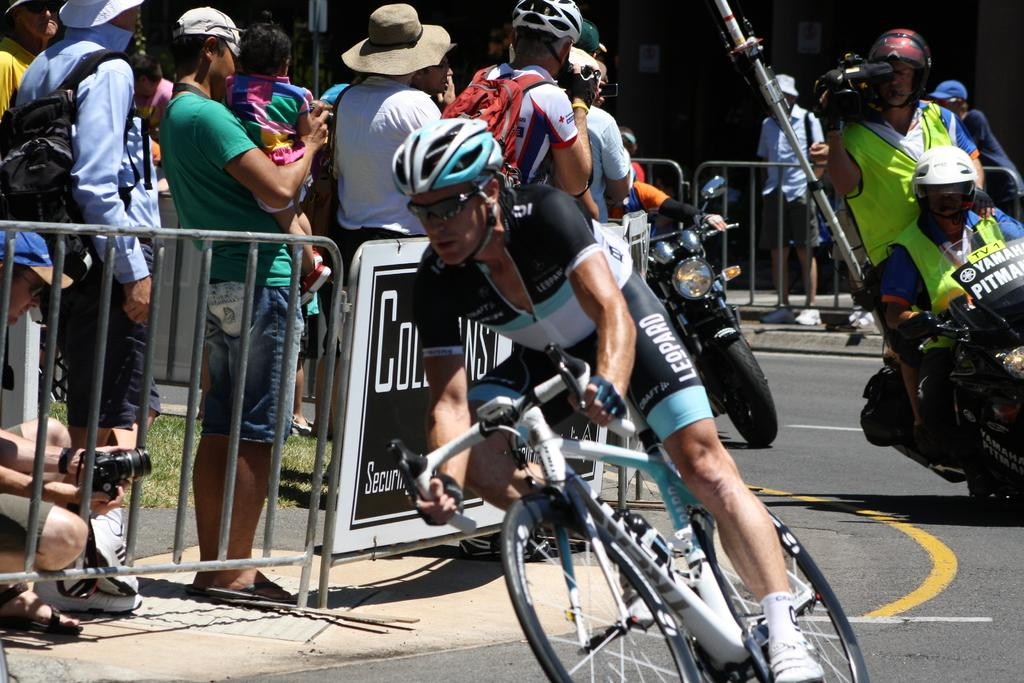Who or what is present in the image? There are people in the image. What type of vehicles can be seen in the image? There is a motorcycle and a bicycle in the image. How much money is being exchanged between the people in the image? There is no indication of money being exchanged in the image. What type of jam is being spread on the motorcycle in the image? There is no jam or any food item present in the image, and the motorcycle is not being used for any such purpose. 